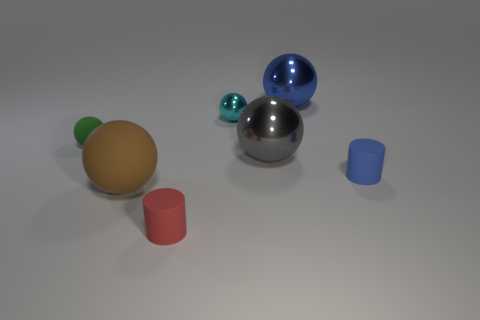Does the cyan object have the same shape as the tiny blue matte thing?
Make the answer very short. No. What number of matte things are either gray things or purple cylinders?
Make the answer very short. 0. What number of large brown things are there?
Your response must be concise. 1. The other metallic thing that is the same size as the gray shiny thing is what color?
Offer a very short reply. Blue. Is the size of the gray object the same as the red cylinder?
Keep it short and to the point. No. There is a brown object; does it have the same size as the metal ball behind the tiny cyan sphere?
Provide a succinct answer. Yes. There is a small thing that is on the left side of the blue cylinder and in front of the gray ball; what color is it?
Your response must be concise. Red. Are there more shiny objects right of the tiny blue thing than objects that are on the right side of the brown object?
Offer a terse response. No. The brown object that is made of the same material as the small red cylinder is what size?
Your answer should be compact. Large. What number of metallic objects are to the left of the large shiny object right of the gray shiny ball?
Your answer should be very brief. 2. 